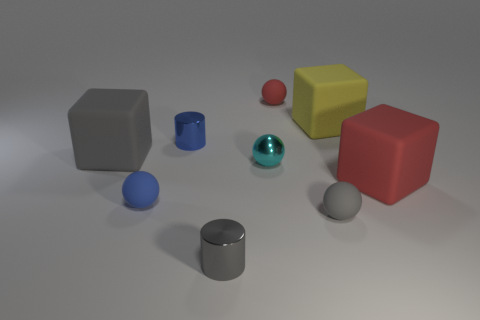Is the material of the gray thing in front of the tiny gray rubber sphere the same as the small gray sphere?
Offer a terse response. No. What number of other things are the same shape as the tiny blue rubber object?
Your answer should be compact. 3. How many small blue spheres are behind the gray thing behind the gray rubber thing that is to the right of the small red thing?
Ensure brevity in your answer.  0. What is the color of the cylinder that is behind the red matte cube?
Offer a terse response. Blue. Does the small rubber thing behind the large gray rubber cube have the same color as the metallic sphere?
Make the answer very short. No. What is the size of the gray object that is the same shape as the yellow thing?
Your response must be concise. Large. Are there any other things that have the same size as the blue metallic thing?
Your answer should be compact. Yes. There is a cube that is to the left of the shiny cylinder behind the matte object to the right of the big yellow matte block; what is its material?
Make the answer very short. Rubber. Is the number of red rubber balls to the left of the cyan metallic thing greater than the number of large red blocks that are behind the small red rubber thing?
Offer a very short reply. No. Is the size of the blue metallic thing the same as the cyan shiny ball?
Your response must be concise. Yes. 